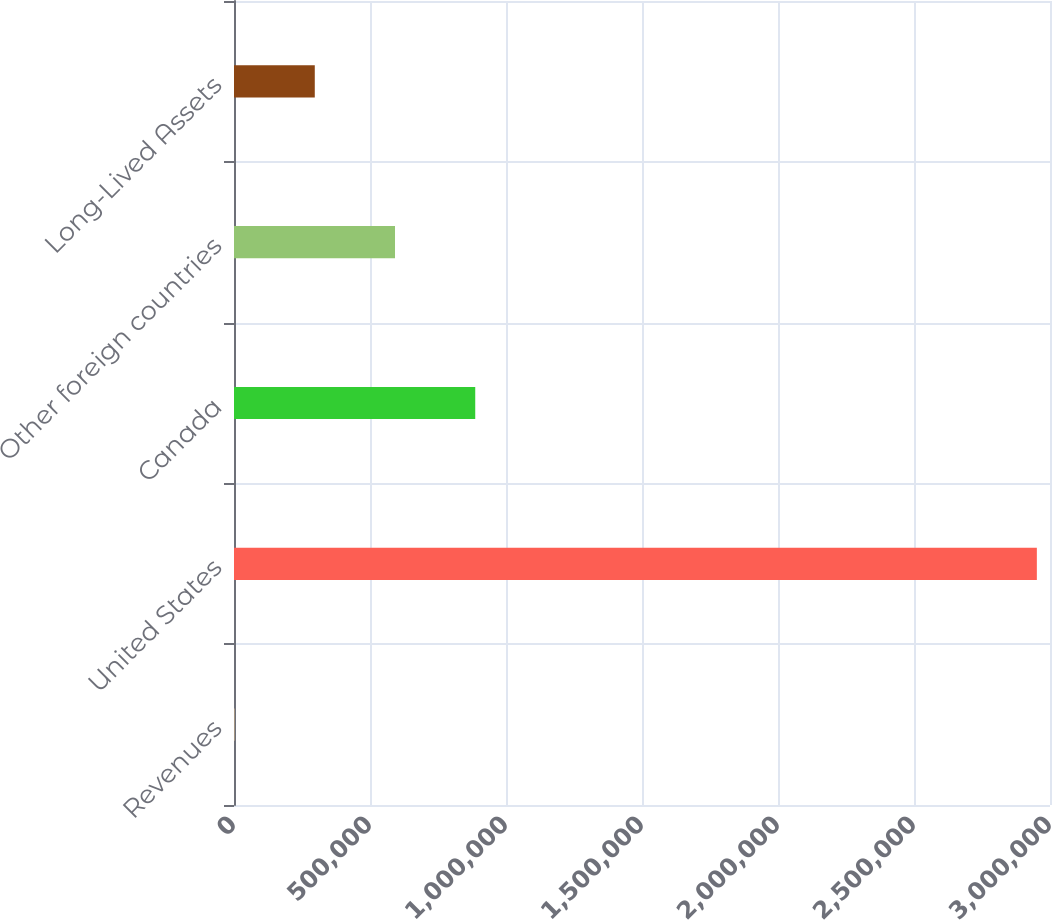<chart> <loc_0><loc_0><loc_500><loc_500><bar_chart><fcel>Revenues<fcel>United States<fcel>Canada<fcel>Other foreign countries<fcel>Long-Lived Assets<nl><fcel>2013<fcel>2.95167e+06<fcel>886911<fcel>591945<fcel>296979<nl></chart> 